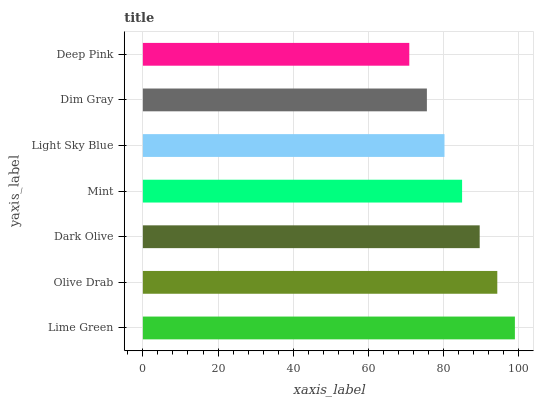Is Deep Pink the minimum?
Answer yes or no. Yes. Is Lime Green the maximum?
Answer yes or no. Yes. Is Olive Drab the minimum?
Answer yes or no. No. Is Olive Drab the maximum?
Answer yes or no. No. Is Lime Green greater than Olive Drab?
Answer yes or no. Yes. Is Olive Drab less than Lime Green?
Answer yes or no. Yes. Is Olive Drab greater than Lime Green?
Answer yes or no. No. Is Lime Green less than Olive Drab?
Answer yes or no. No. Is Mint the high median?
Answer yes or no. Yes. Is Mint the low median?
Answer yes or no. Yes. Is Lime Green the high median?
Answer yes or no. No. Is Dark Olive the low median?
Answer yes or no. No. 